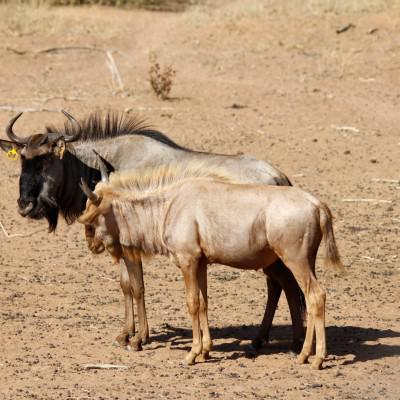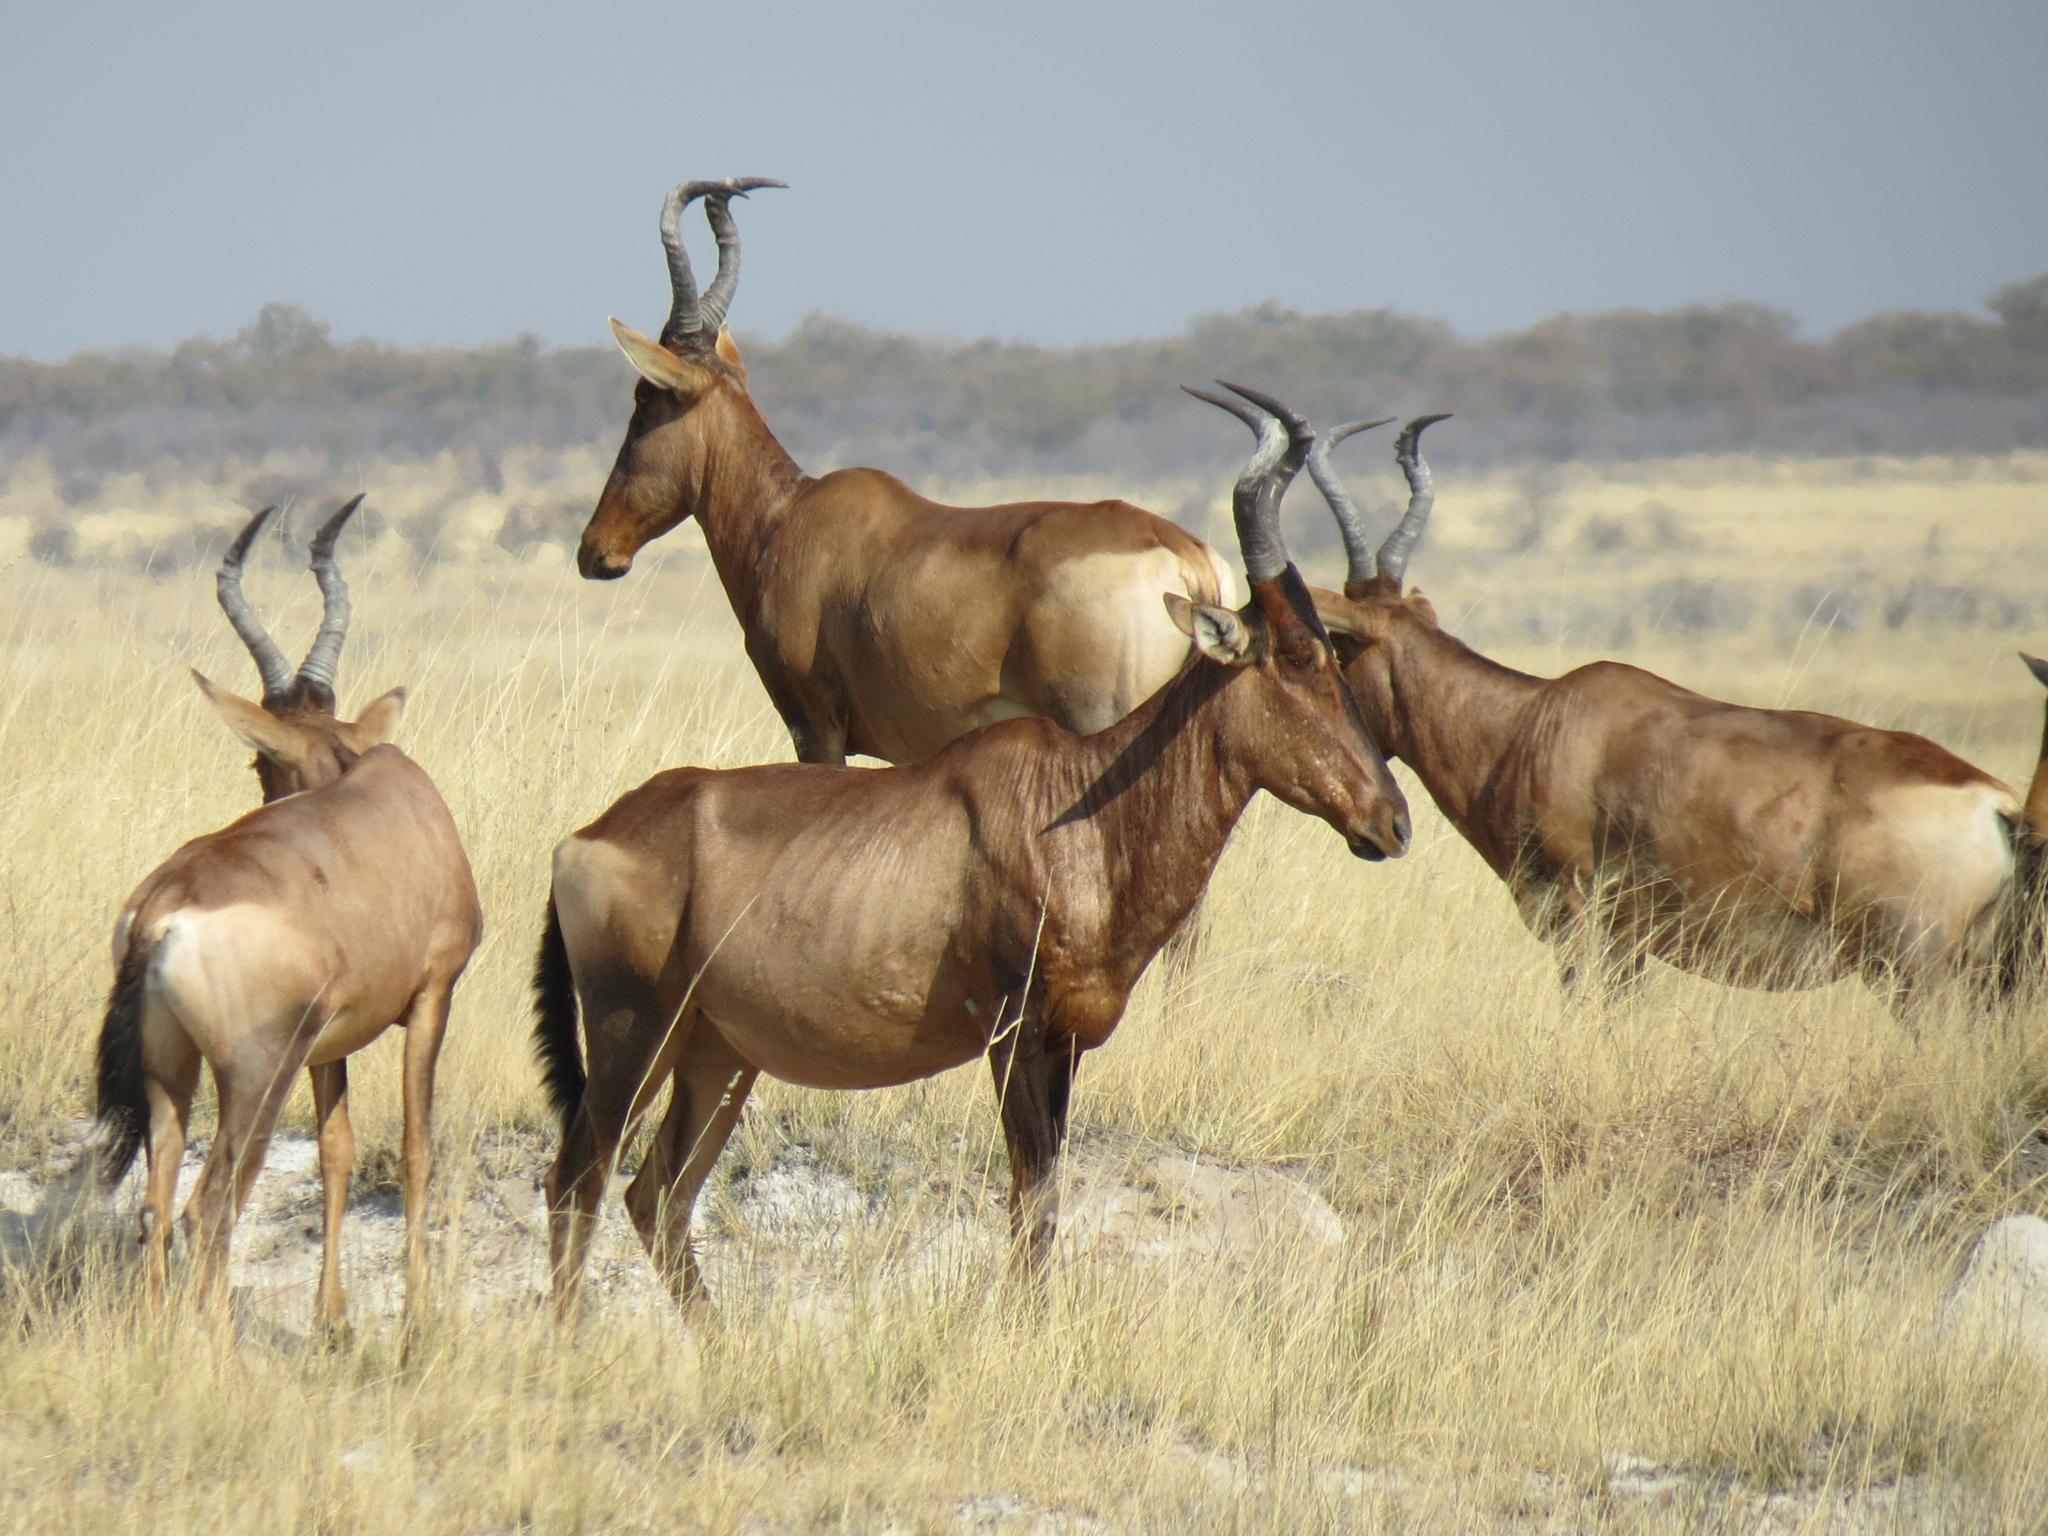The first image is the image on the left, the second image is the image on the right. Examine the images to the left and right. Is the description "There are more hooved, horned animals on the right than on the left." accurate? Answer yes or no. Yes. The first image is the image on the left, the second image is the image on the right. Analyze the images presented: Is the assertion "There are exactly two animals in the image on the left." valid? Answer yes or no. Yes. 